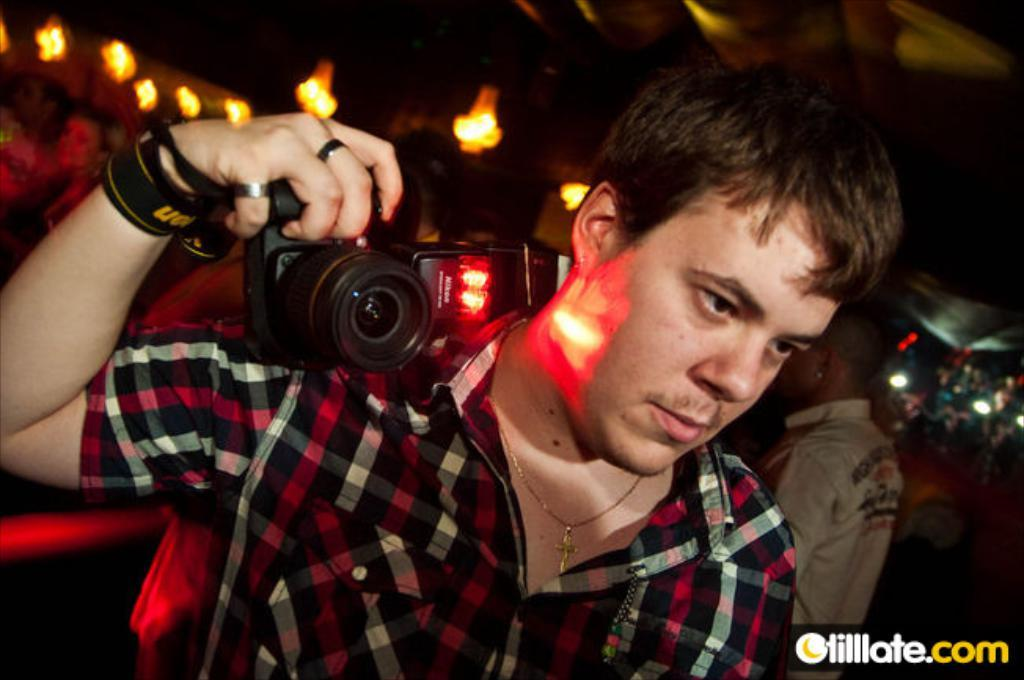What is the main subject of the image? The main subject of the image is a man. What is the man doing in the image? The man is standing in the image. What object is the man holding in his hand? The man is holding a camera in his hand. What type of giants can be seen in the image? There are no giants present in the image; it features a man holding a camera. What role does the actor play in the image? There is no actor or specific role mentioned in the image, as it only shows a man holding a camera. 